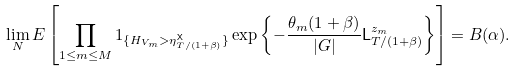<formula> <loc_0><loc_0><loc_500><loc_500>\lim _ { N } E \left [ \prod _ { 1 \leq m \leq M } 1 _ { \{ H _ { V _ { m } } > \eta ^ { \mathsf X } _ { T / ( 1 + \beta ) } \} } \exp \left \{ - \frac { \theta _ { m } ( 1 + \beta ) } { | G | } { \mathsf L } ^ { z _ { m } } _ { T / ( 1 + \beta ) } \right \} \right ] = B ( \alpha ) .</formula> 